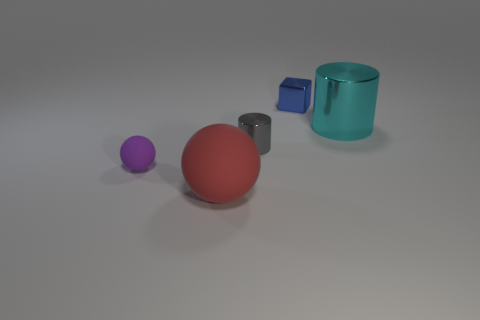There is a large thing that is behind the large rubber object; is its shape the same as the thing that is left of the big red matte sphere?
Offer a very short reply. No. What number of objects are tiny cubes or small cubes that are left of the cyan metal object?
Provide a short and direct response. 1. What number of other objects are there of the same shape as the cyan thing?
Your response must be concise. 1. Do the large thing behind the purple rubber sphere and the block have the same material?
Make the answer very short. Yes. What number of things are purple rubber things or big brown cubes?
Give a very brief answer. 1. There is a red matte object that is the same shape as the small purple rubber thing; what is its size?
Offer a terse response. Large. What is the size of the gray cylinder?
Provide a succinct answer. Small. Are there more gray things in front of the gray thing than tiny purple rubber spheres?
Your answer should be very brief. No. Are there any other things that have the same material as the tiny gray cylinder?
Make the answer very short. Yes. Do the tiny thing on the left side of the tiny gray metallic thing and the metallic thing left of the tiny block have the same color?
Provide a succinct answer. No. 